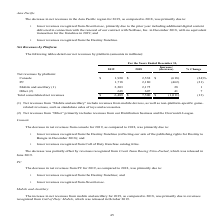According to Activision Blizzard's financial document, What does Net revenues from “Mobile and ancillary” include? Based on the financial document, the answer is revenues from mobile devices, as well as non-platform-specific game-related revenues, such as standalone sales of toys and accessories.. Also, What does Net revenues from “Other” include? revenues from our Distribution business and the Overwatch League.. The document states: "(2) Net revenues from “Other” primarily includes revenues from our Distribution business and the Overwatch League...." Also, What is the net revenue from Console in 2019? According to the financial document, $1,920 (in millions). The relevant text states: "Console $ 1,920 $ 2,538 $ (618) (24)%..." Also, can you calculate: What is the total consolidated net revenues of Console PC in 2019? Based on the calculation: $1,920+1,718, the result is 3638 (in millions). This is based on the information: "PC 1,718 2,180 (462) (21) Console $ 1,920 $ 2,538 $ (618) (24)%..." The key data points involved are: 1,718, 1,920. Also, can you calculate: What is the total consolidated net revenues of Console PC in 2018? Based on the calculation: $2,538+2,180, the result is 4718 (in millions). This is based on the information: "Console $ 1,920 $ 2,538 $ (618) (24)% PC 1,718 2,180 (462) (21)..." The key data points involved are: 2,180, 2,538. Also, can you calculate: What is the percentage of total consolidated net revenues in 2019 that consists of net revenue from PC? Based on the calculation: ($1,718/$6,489), the result is 26.48 (percentage). This is based on the information: "PC 1,718 2,180 (462) (21) Total consolidated net revenues $ 6,489 $ 7,500 $ (1,011) (13)..." The key data points involved are: 1,718, 6,489. 